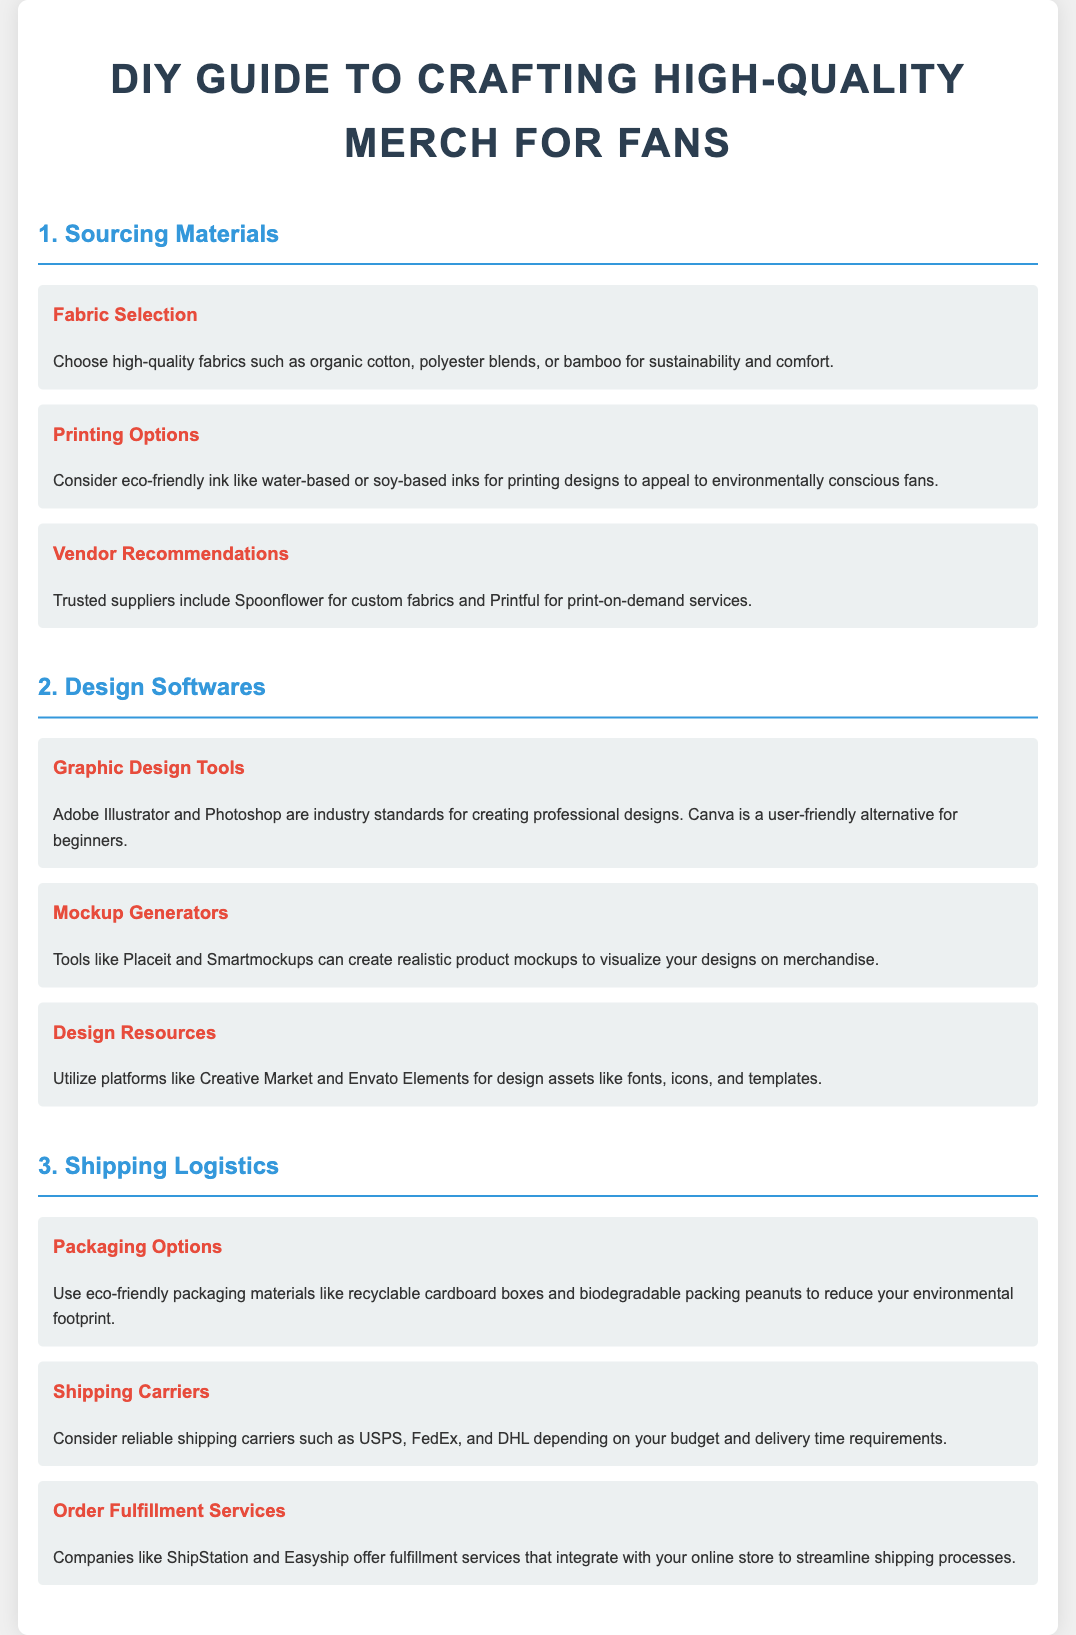What are the recommended fabrics for merch? The document lists organic cotton, polyester blends, and bamboo as high-quality fabric options for merch.
Answer: organic cotton, polyester blends, bamboo Which printing option is suggested for environmentally conscious fans? Eco-friendly ink such as water-based or soy-based inks is recommended for printing designs.
Answer: water-based or soy-based inks What graphic design tool is considered an industry standard? Adobe Illustrator is recognized as an industry standard for graphic design.
Answer: Adobe Illustrator Name a mockup generator mentioned in the document. Placeit is one of the tools mentioned for creating realistic product mockups.
Answer: Placeit What type of packaging materials are suggested for eco-friendliness? The document suggests using recyclable cardboard boxes and biodegradable packing peanuts as packaging materials.
Answer: recyclable cardboard boxes, biodegradable packing peanuts Which shipping carrier is recommended depending on budget and delivery time? USPS is one of the reliable shipping carriers mentioned which can be chosen depending on budget and delivery time requirements.
Answer: USPS What fulfillment service can help streamline shipping processes? ShipStation is mentioned as a company offering fulfillment services that integrate with online stores.
Answer: ShipStation How many sections does the document contain? The document contains three main sections: Sourcing Materials, Design Softwares, and Shipping Logistics.
Answer: Three What is the title of the guide? The title of the document clearly states that it is a DIY Guide to Crafting High-Quality Merch for Fans.
Answer: DIY Guide to Crafting High-Quality Merch for Fans Which design resource platform is suggested for design assets? Creative Market is one of the platforms recommended for obtaining design assets like fonts and templates.
Answer: Creative Market 